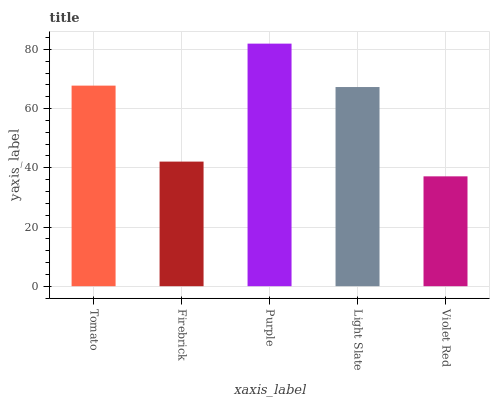Is Violet Red the minimum?
Answer yes or no. Yes. Is Purple the maximum?
Answer yes or no. Yes. Is Firebrick the minimum?
Answer yes or no. No. Is Firebrick the maximum?
Answer yes or no. No. Is Tomato greater than Firebrick?
Answer yes or no. Yes. Is Firebrick less than Tomato?
Answer yes or no. Yes. Is Firebrick greater than Tomato?
Answer yes or no. No. Is Tomato less than Firebrick?
Answer yes or no. No. Is Light Slate the high median?
Answer yes or no. Yes. Is Light Slate the low median?
Answer yes or no. Yes. Is Tomato the high median?
Answer yes or no. No. Is Purple the low median?
Answer yes or no. No. 